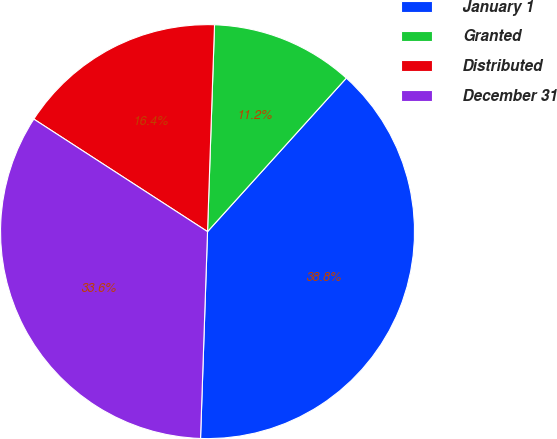<chart> <loc_0><loc_0><loc_500><loc_500><pie_chart><fcel>January 1<fcel>Granted<fcel>Distributed<fcel>December 31<nl><fcel>38.84%<fcel>11.16%<fcel>16.39%<fcel>33.61%<nl></chart> 